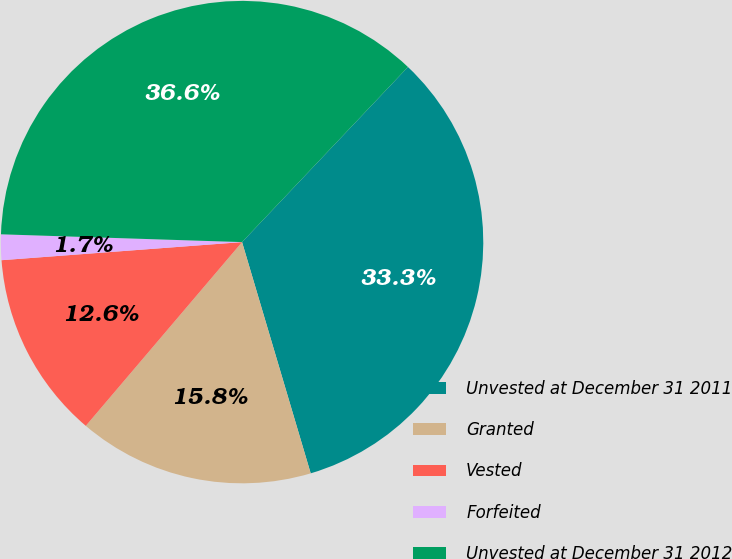<chart> <loc_0><loc_0><loc_500><loc_500><pie_chart><fcel>Unvested at December 31 2011<fcel>Granted<fcel>Vested<fcel>Forfeited<fcel>Unvested at December 31 2012<nl><fcel>33.34%<fcel>15.81%<fcel>12.59%<fcel>1.71%<fcel>36.56%<nl></chart> 